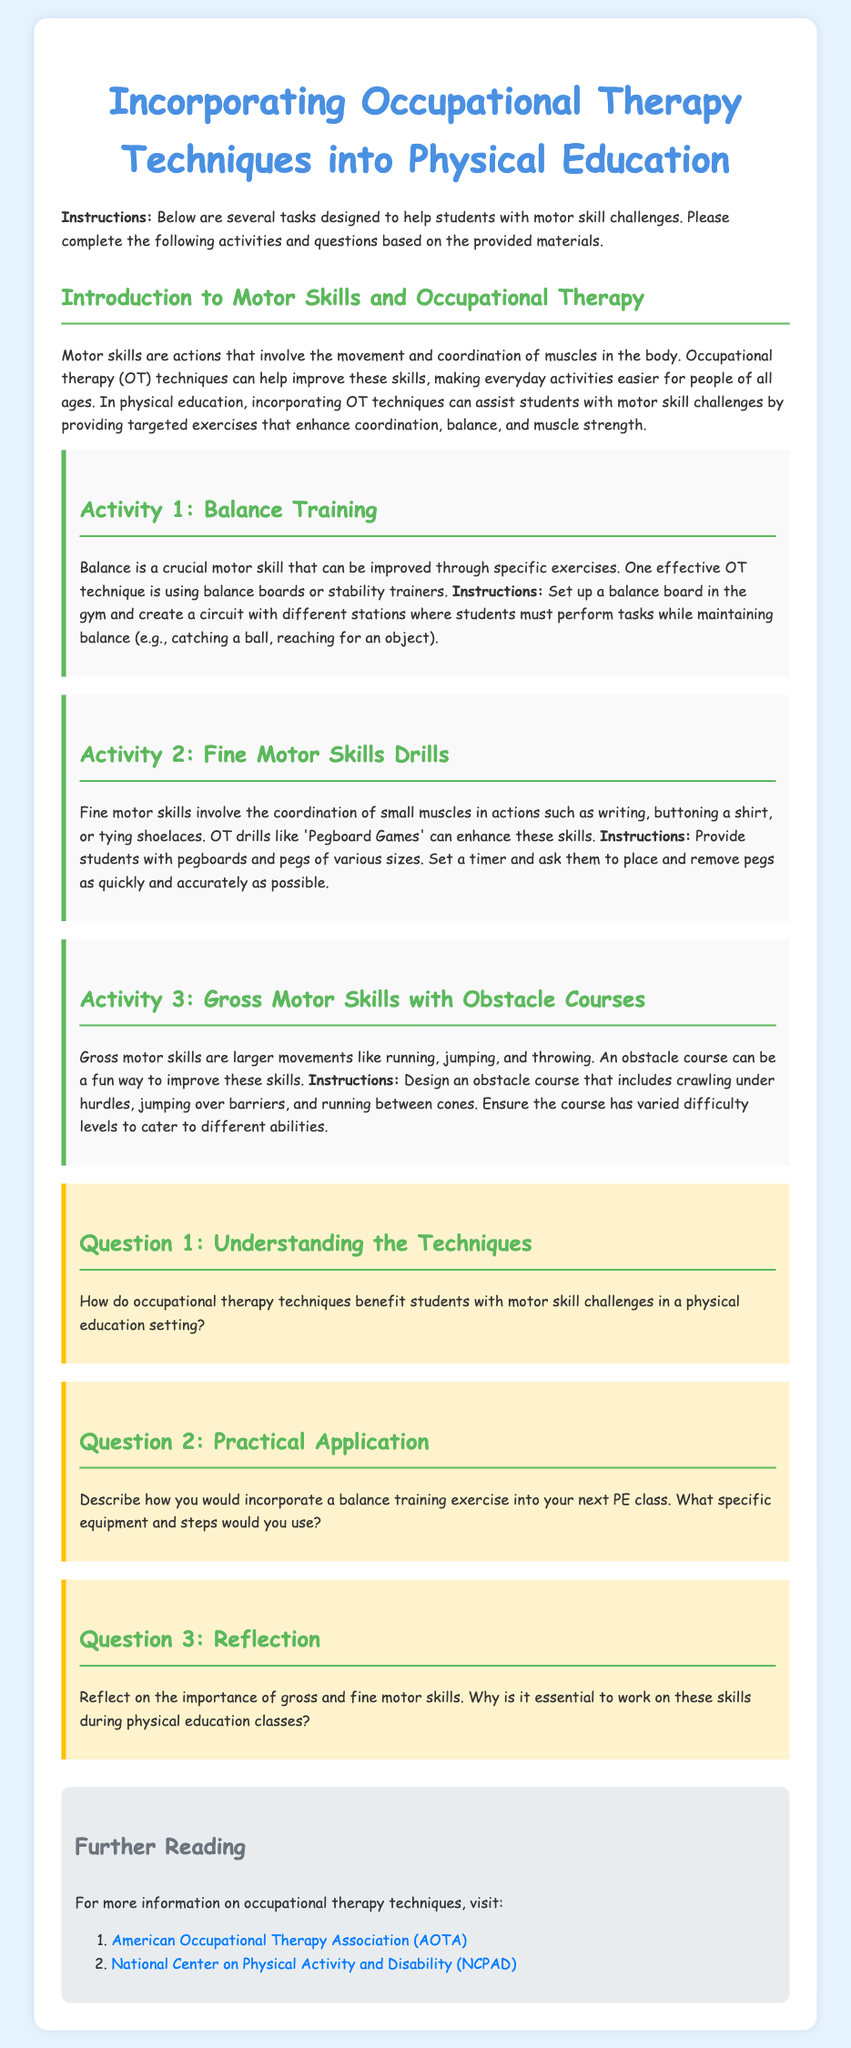What is the title of the document? The title is specified in the `<title>` tag of the HTML document.
Answer: Incorporating Occupational Therapy Techniques into Physical Education How many activities are mentioned in the document? The document lists three specific activities in separate sections.
Answer: 3 What is the focus of Activity 2? Activity 2 is focused on enhancing coordination of small muscles through specific drills.
Answer: Fine Motor Skills Drills Which technique is recommended for balance training? The document mentions the use of a specific type of equipment for balance training.
Answer: Balance boards What should students use in Activity 1 to maintain balance? The first activity suggests a piece of equipment that helps improve balance.
Answer: Balance board In which section do you find further reading resources? The section dedicated to additional resources is named distinctly in the HTML.
Answer: Further Reading What is the main goal of incorporating OT techniques in PE? The introduction section states the overall intention of applying OT methods in physical education.
Answer: Improve motor skills What exercise is included in Activity 3? Activity 3 describes a specific type of physical challenge aimed at improving larger movements.
Answer: Obstacle courses What is emphasized in the reflection question? The reflection question highlights the significance of particular skills during physical education.
Answer: Importance of gross and fine motor skills 